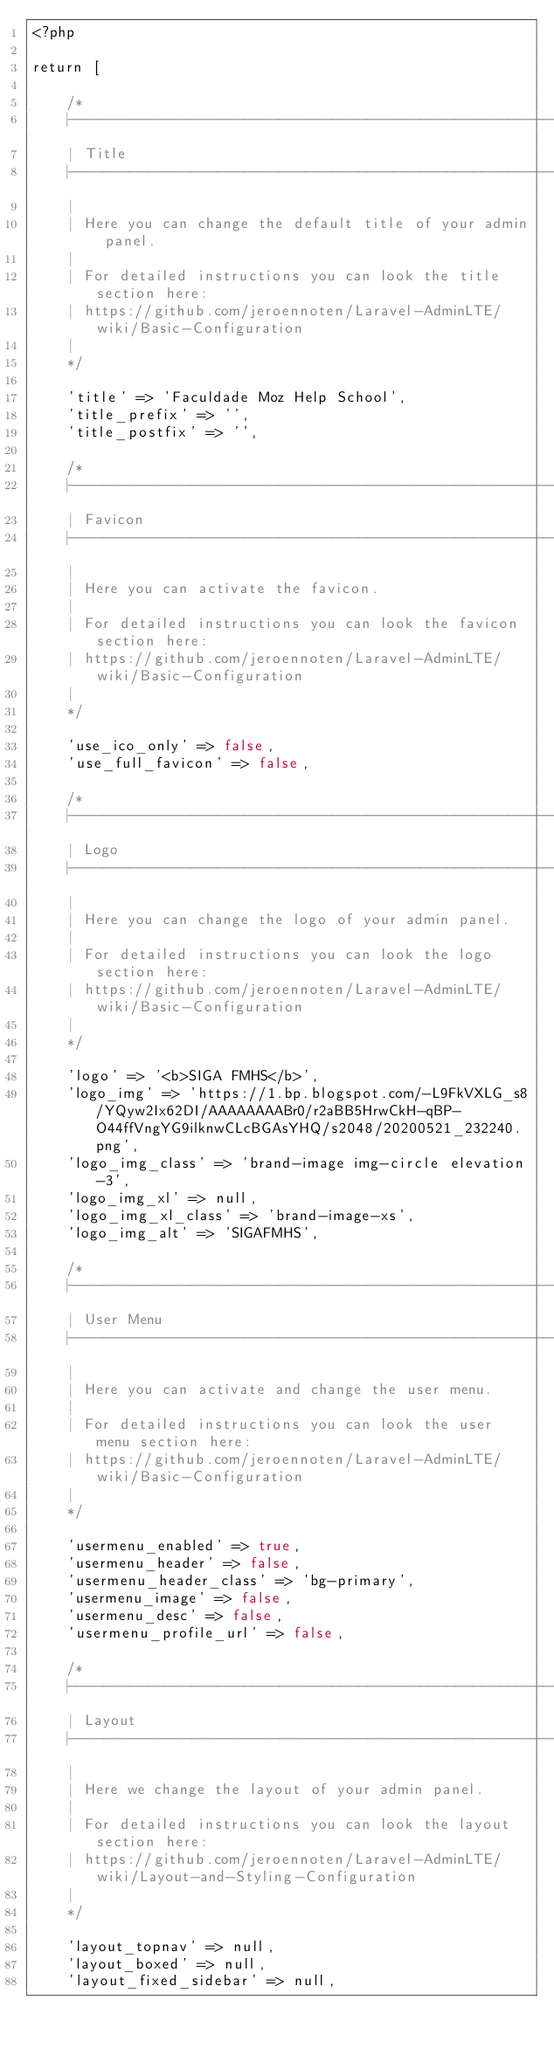<code> <loc_0><loc_0><loc_500><loc_500><_PHP_><?php

return [

    /*
    |--------------------------------------------------------------------------
    | Title
    |--------------------------------------------------------------------------
    |
    | Here you can change the default title of your admin panel.
    |
    | For detailed instructions you can look the title section here:
    | https://github.com/jeroennoten/Laravel-AdminLTE/wiki/Basic-Configuration
    |
    */

    'title' => 'Faculdade Moz Help School',
    'title_prefix' => '',
    'title_postfix' => '',

    /*
    |--------------------------------------------------------------------------
    | Favicon
    |--------------------------------------------------------------------------
    |
    | Here you can activate the favicon.
    |
    | For detailed instructions you can look the favicon section here:
    | https://github.com/jeroennoten/Laravel-AdminLTE/wiki/Basic-Configuration
    |
    */

    'use_ico_only' => false,
    'use_full_favicon' => false,

    /*
    |--------------------------------------------------------------------------
    | Logo
    |--------------------------------------------------------------------------
    |
    | Here you can change the logo of your admin panel.
    |
    | For detailed instructions you can look the logo section here:
    | https://github.com/jeroennoten/Laravel-AdminLTE/wiki/Basic-Configuration
    |
    */

    'logo' => '<b>SIGA FMHS</b>',
    'logo_img' => 'https://1.bp.blogspot.com/-L9FkVXLG_s8/YQyw2Ix62DI/AAAAAAAABr0/r2aBB5HrwCkH-qBP-O44ffVngYG9ilknwCLcBGAsYHQ/s2048/20200521_232240.png',
    'logo_img_class' => 'brand-image img-circle elevation-3',
    'logo_img_xl' => null,
    'logo_img_xl_class' => 'brand-image-xs',
    'logo_img_alt' => 'SIGAFMHS',

    /*
    |--------------------------------------------------------------------------
    | User Menu
    |--------------------------------------------------------------------------
    |
    | Here you can activate and change the user menu.
    |
    | For detailed instructions you can look the user menu section here:
    | https://github.com/jeroennoten/Laravel-AdminLTE/wiki/Basic-Configuration
    |
    */

    'usermenu_enabled' => true,
    'usermenu_header' => false,
    'usermenu_header_class' => 'bg-primary',
    'usermenu_image' => false,
    'usermenu_desc' => false,
    'usermenu_profile_url' => false,

    /*
    |--------------------------------------------------------------------------
    | Layout
    |--------------------------------------------------------------------------
    |
    | Here we change the layout of your admin panel.
    |
    | For detailed instructions you can look the layout section here:
    | https://github.com/jeroennoten/Laravel-AdminLTE/wiki/Layout-and-Styling-Configuration
    |
    */

    'layout_topnav' => null,
    'layout_boxed' => null,
    'layout_fixed_sidebar' => null,</code> 